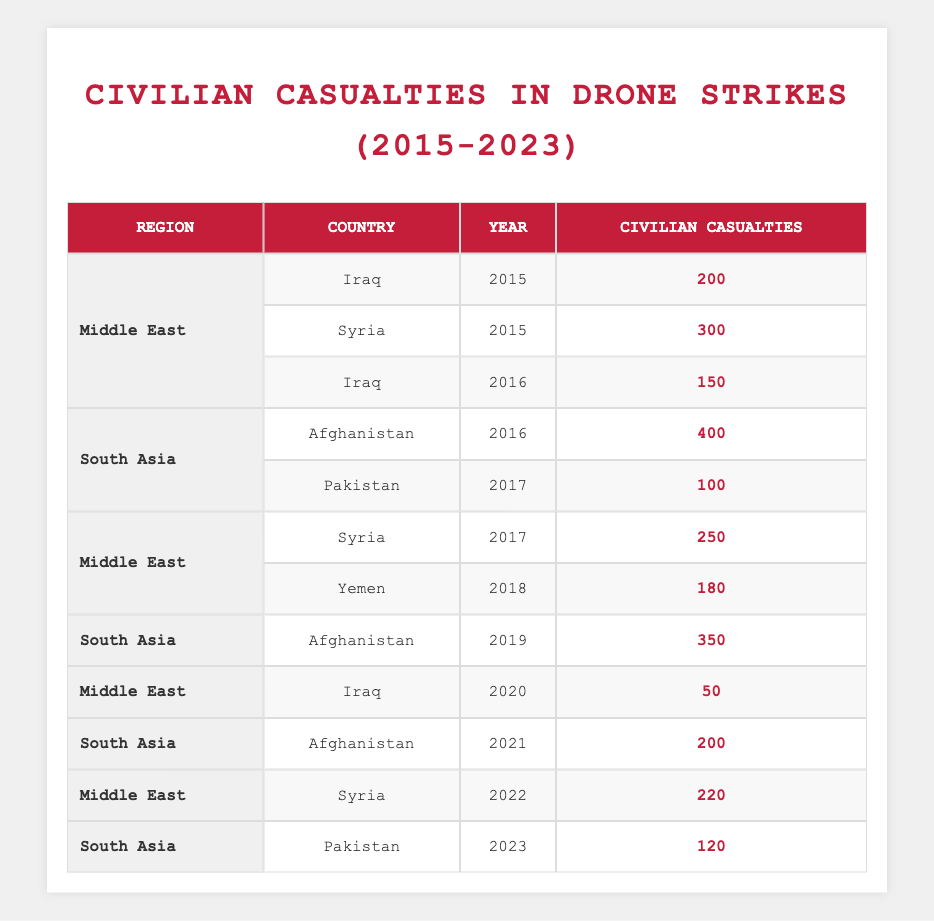What is the total number of civilian casualties in drone strikes in Iraq from 2015 to 2023? In the table, Iraq has civilian casualties listed for 2015 (200), 2016 (150), and 2020 (50). To find the total, add these values: 200 + 150 + 50 = 400.
Answer: 400 Which country had the highest civilian casualties in 2016? In 2016, the table shows Afghanistan with 400 casualties and Iraq with 150 casualties. Comparing these, Afghanistan has the highest number.
Answer: Afghanistan Did civilian casualties in Syria increase from 2015 to 2017? In 2015, civilian casualties in Syria were 300. In 2017, they increased to 250; however, this is a decrease. Thus, the statement is false.
Answer: No What is the average number of civilian casualties in Afghanistan from 2016 to 2021? Afghanistan had civilian casualties of 400 (2016), 350 (2019), and 200 (2021). To find the average, first calculate the total: 400 + 350 + 200 = 950, then divide by the number of entries (3), which is 950 / 3 = approximately 316.67.
Answer: Approximately 316.67 In which year did Yemen experience civilian casualties, and how many were there? Looking through the table, Yemen had civilian casualties listed only for 2018, with a total of 180 casualties.
Answer: 2018, 180 How many civilian casualties were reported in the South Asia region across all years? The South Asia region has casualties listed for Afghanistan and Pakistan from 2016 to 2023. The totals are 400 (2016), 350 (2019), 200 (2021), 100 (2017), and 120 (2023). Adding these together yields: 400 + 350 + 200 + 100 + 120 = 1170.
Answer: 1170 Was there any year from 2015 to 2023 where there were zero civilian casualties in the Middle East? Reviewing the Middle East region, all years listed have casualties (2015, 2016, 2017, 2018, 2020, 2021, 2022). Thus, the statement is false.
Answer: No What was the year with the minimum civilian casualties in the Middle East, and what was the number? By examining the Middle East data in the table, the year 2020 has the minimum casualties with a count of 50.
Answer: 2020, 50 Which region had the second-highest total of civilian casualties, and what was the total? The Middle East had a total of 1300 casualties (200 + 300 + 150 + 250 + 180 + 50 + 220 = 1300). South Asia comes next with 1170 casualties. Therefore, the second-highest total is that of South Asia.
Answer: South Asia, 1170 